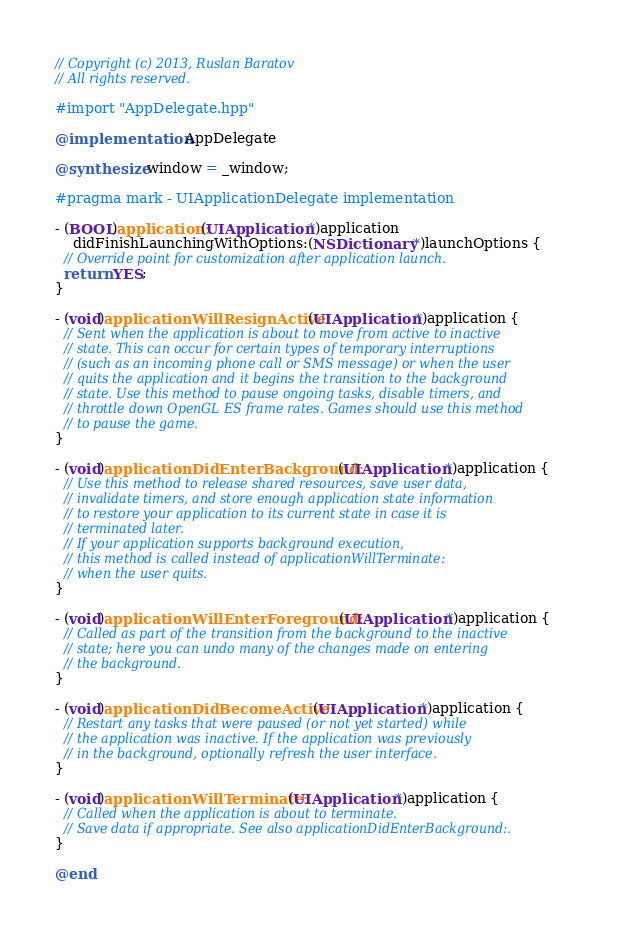<code> <loc_0><loc_0><loc_500><loc_500><_ObjectiveC_>// Copyright (c) 2013, Ruslan Baratov
// All rights reserved.

#import "AppDelegate.hpp"

@implementation AppDelegate

@synthesize window = _window;

#pragma mark - UIApplicationDelegate implementation

- (BOOL)application:(UIApplication *)application
    didFinishLaunchingWithOptions:(NSDictionary *)launchOptions {
  // Override point for customization after application launch.
  return YES;
}

- (void)applicationWillResignActive:(UIApplication *)application {
  // Sent when the application is about to move from active to inactive
  // state. This can occur for certain types of temporary interruptions
  // (such as an incoming phone call or SMS message) or when the user
  // quits the application and it begins the transition to the background
  // state. Use this method to pause ongoing tasks, disable timers, and
  // throttle down OpenGL ES frame rates. Games should use this method
  // to pause the game.
}

- (void)applicationDidEnterBackground:(UIApplication *)application {
  // Use this method to release shared resources, save user data,
  // invalidate timers, and store enough application state information
  // to restore your application to its current state in case it is
  // terminated later.
  // If your application supports background execution,
  // this method is called instead of applicationWillTerminate:
  // when the user quits.
}

- (void)applicationWillEnterForeground:(UIApplication *)application {
  // Called as part of the transition from the background to the inactive
  // state; here you can undo many of the changes made on entering
  // the background.
}

- (void)applicationDidBecomeActive:(UIApplication *)application {
  // Restart any tasks that were paused (or not yet started) while
  // the application was inactive. If the application was previously
  // in the background, optionally refresh the user interface.
}

- (void)applicationWillTerminate:(UIApplication *)application {
  // Called when the application is about to terminate.
  // Save data if appropriate. See also applicationDidEnterBackground:.
}

@end
</code> 